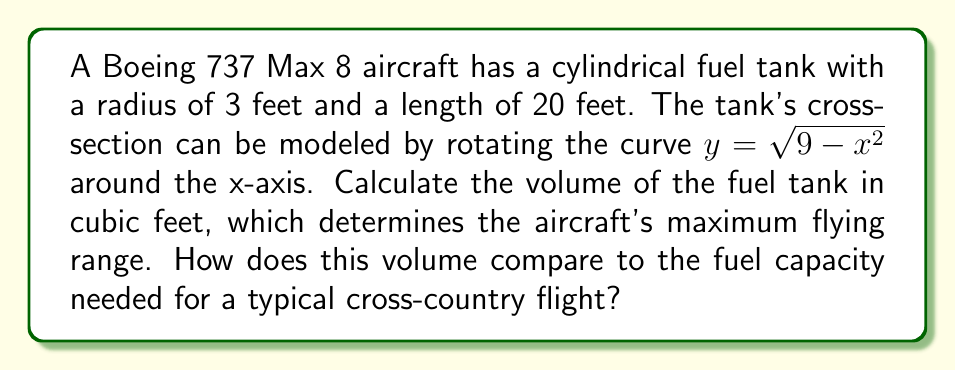Can you solve this math problem? To calculate the volume of the cylindrical fuel tank, we'll use the method of integration by rotating a curve around the x-axis. Here's the step-by-step process:

1) The curve given is $y = \sqrt{9 - x^2}$, which represents a semi-circle with radius 3.

2) The volume formula for rotating a curve around the x-axis is:

   $$V = \pi \int_{a}^{b} [f(x)]^2 dx$$

   where $f(x)$ is our curve and $[a,b]$ is the interval of rotation.

3) In this case, $f(x) = \sqrt{9 - x^2}$, $a = -3$, and $b = 3$ (the endpoints of the diameter).

4) Substituting into the formula:

   $$V = \pi \int_{-3}^{3} (9 - x^2) dx$$

5) Evaluating the integral:

   $$\begin{align}
   V &= \pi \left[9x - \frac{x^3}{3}\right]_{-3}^{3} \\
   &= \pi \left[(27 - 9) - (-27 - (-9))\right] \\
   &= \pi (18 + 36) \\
   &= 54\pi
   \end{align}$$

6) This gives us the volume of a cylinder with length 6 feet (the diameter of the circle).

7) To get the volume of the 20-foot long tank, we multiply by $\frac{20}{6}$:

   $$V_{total} = 54\pi \cdot \frac{20}{6} = 180\pi \approx 565.49 \text{ cubic feet}$$

For context, a typical narrow-body aircraft like the Boeing 737 Max 8 has a fuel capacity of around 6,875 gallons or about 918 cubic feet. The calculated volume is more than half of this, which is reasonable for a main fuel tank.
Answer: The volume of the fuel tank is $180\pi$ cubic feet, or approximately 565.49 cubic feet. 